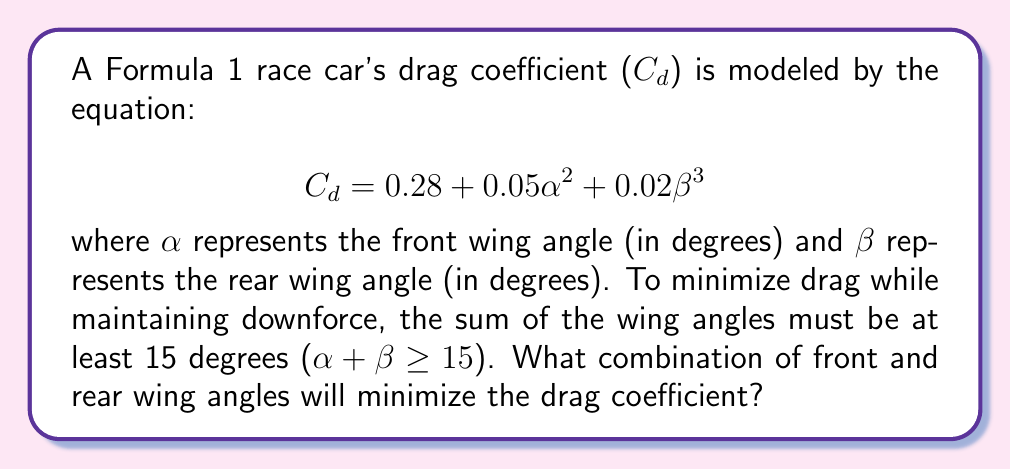Can you answer this question? To solve this optimization problem, we'll use the method of Lagrange multipliers:

1) First, let's define our objective function and constraint:
   $$f(\alpha, \beta) = 0.28 + 0.05\alpha^2 + 0.02\beta^3$$
   $$g(\alpha, \beta) = \alpha + \beta - 15 = 0$$

2) We form the Lagrangian:
   $$L(\alpha, \beta, \lambda) = f(\alpha, \beta) - \lambda g(\alpha, \beta)$$
   $$L(\alpha, \beta, \lambda) = 0.28 + 0.05\alpha^2 + 0.02\beta^3 - \lambda(\alpha + \beta - 15)$$

3) We then take partial derivatives and set them to zero:
   $$\frac{\partial L}{\partial \alpha} = 0.1\alpha - \lambda = 0$$
   $$\frac{\partial L}{\partial \beta} = 0.06\beta^2 - \lambda = 0$$
   $$\frac{\partial L}{\partial \lambda} = -(\alpha + \beta - 15) = 0$$

4) From the first two equations:
   $$0.1\alpha = 0.06\beta^2$$
   $$\alpha = 0.6\beta^2$$

5) Substituting this into the constraint equation:
   $$0.6\beta^2 + \beta = 15$$
   $$0.6\beta^2 + \beta - 15 = 0$$

6) This is a quadratic equation. We can solve it using the quadratic formula:
   $$\beta = \frac{-1 \pm \sqrt{1^2 - 4(0.6)(-15)}}{2(0.6)}$$
   $$\beta \approx 4.37 \text{ or } -5.70$$

7) Since $\beta$ represents an angle, it must be positive. So $\beta \approx 4.37$.

8) We can now find $\alpha$:
   $$\alpha = 0.6\beta^2 \approx 0.6(4.37^2) \approx 11.46$$

Therefore, the optimal wing angles are approximately:
Front wing ($\alpha$): 11.46°
Rear wing ($\beta$): 4.37°
Answer: Front wing angle ($\alpha$) ≈ 11.46°, Rear wing angle ($\beta$) ≈ 4.37° 